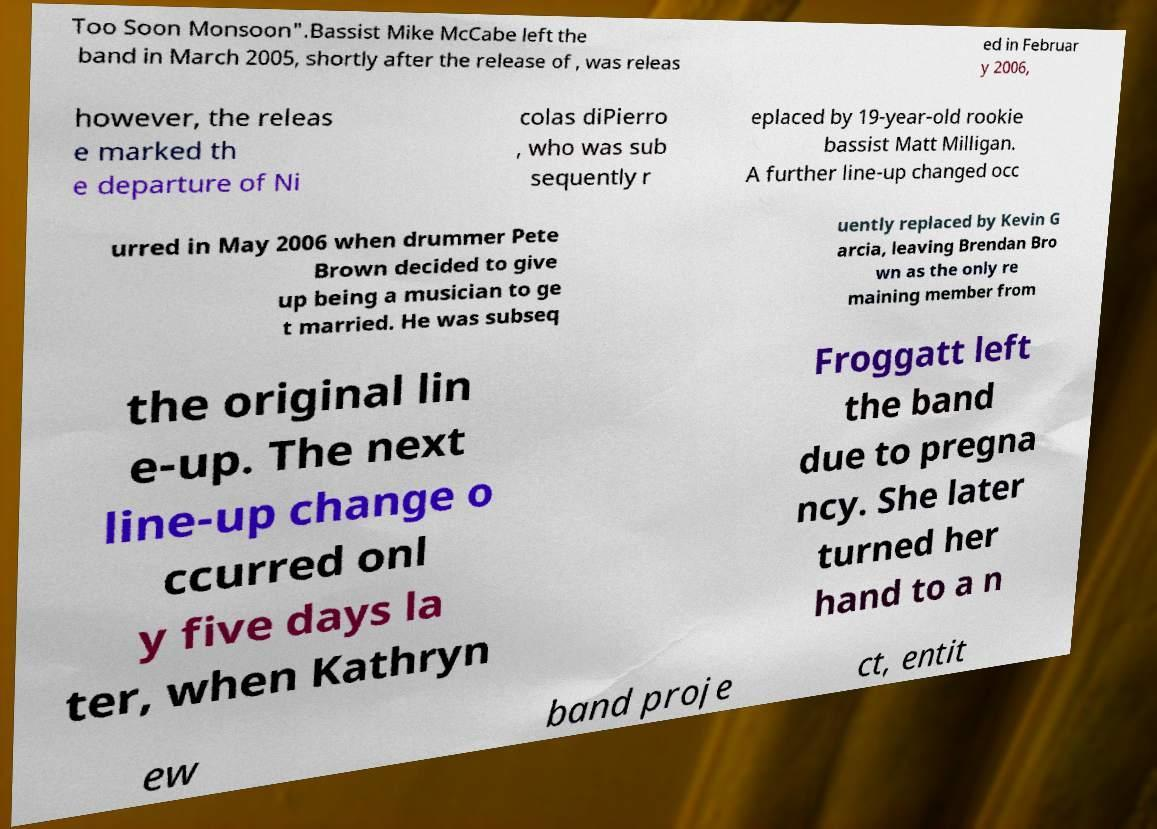There's text embedded in this image that I need extracted. Can you transcribe it verbatim? Too Soon Monsoon".Bassist Mike McCabe left the band in March 2005, shortly after the release of , was releas ed in Februar y 2006, however, the releas e marked th e departure of Ni colas diPierro , who was sub sequently r eplaced by 19-year-old rookie bassist Matt Milligan. A further line-up changed occ urred in May 2006 when drummer Pete Brown decided to give up being a musician to ge t married. He was subseq uently replaced by Kevin G arcia, leaving Brendan Bro wn as the only re maining member from the original lin e-up. The next line-up change o ccurred onl y five days la ter, when Kathryn Froggatt left the band due to pregna ncy. She later turned her hand to a n ew band proje ct, entit 